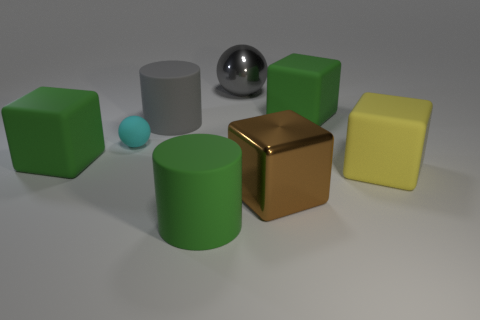Add 1 large metallic spheres. How many objects exist? 9 Subtract all cylinders. How many objects are left? 6 Add 6 cylinders. How many cylinders are left? 8 Add 3 green matte blocks. How many green matte blocks exist? 5 Subtract 2 green cubes. How many objects are left? 6 Subtract all cyan cubes. Subtract all brown metal things. How many objects are left? 7 